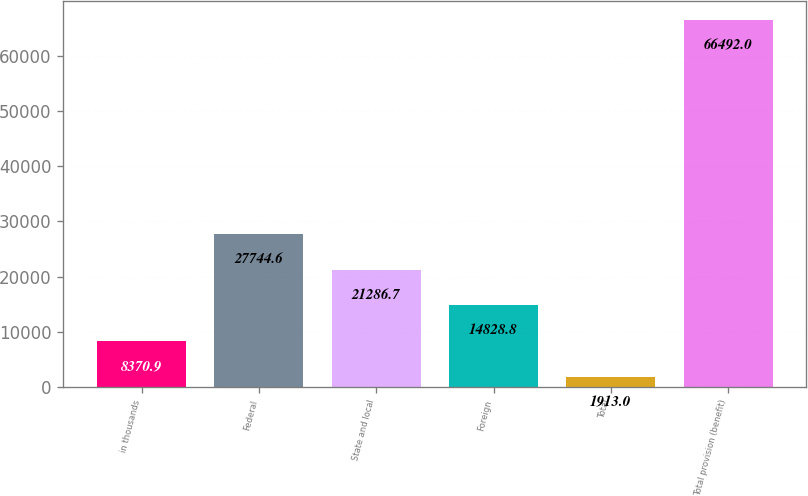<chart> <loc_0><loc_0><loc_500><loc_500><bar_chart><fcel>in thousands<fcel>Federal<fcel>State and local<fcel>Foreign<fcel>Total<fcel>Total provision (benefit)<nl><fcel>8370.9<fcel>27744.6<fcel>21286.7<fcel>14828.8<fcel>1913<fcel>66492<nl></chart> 